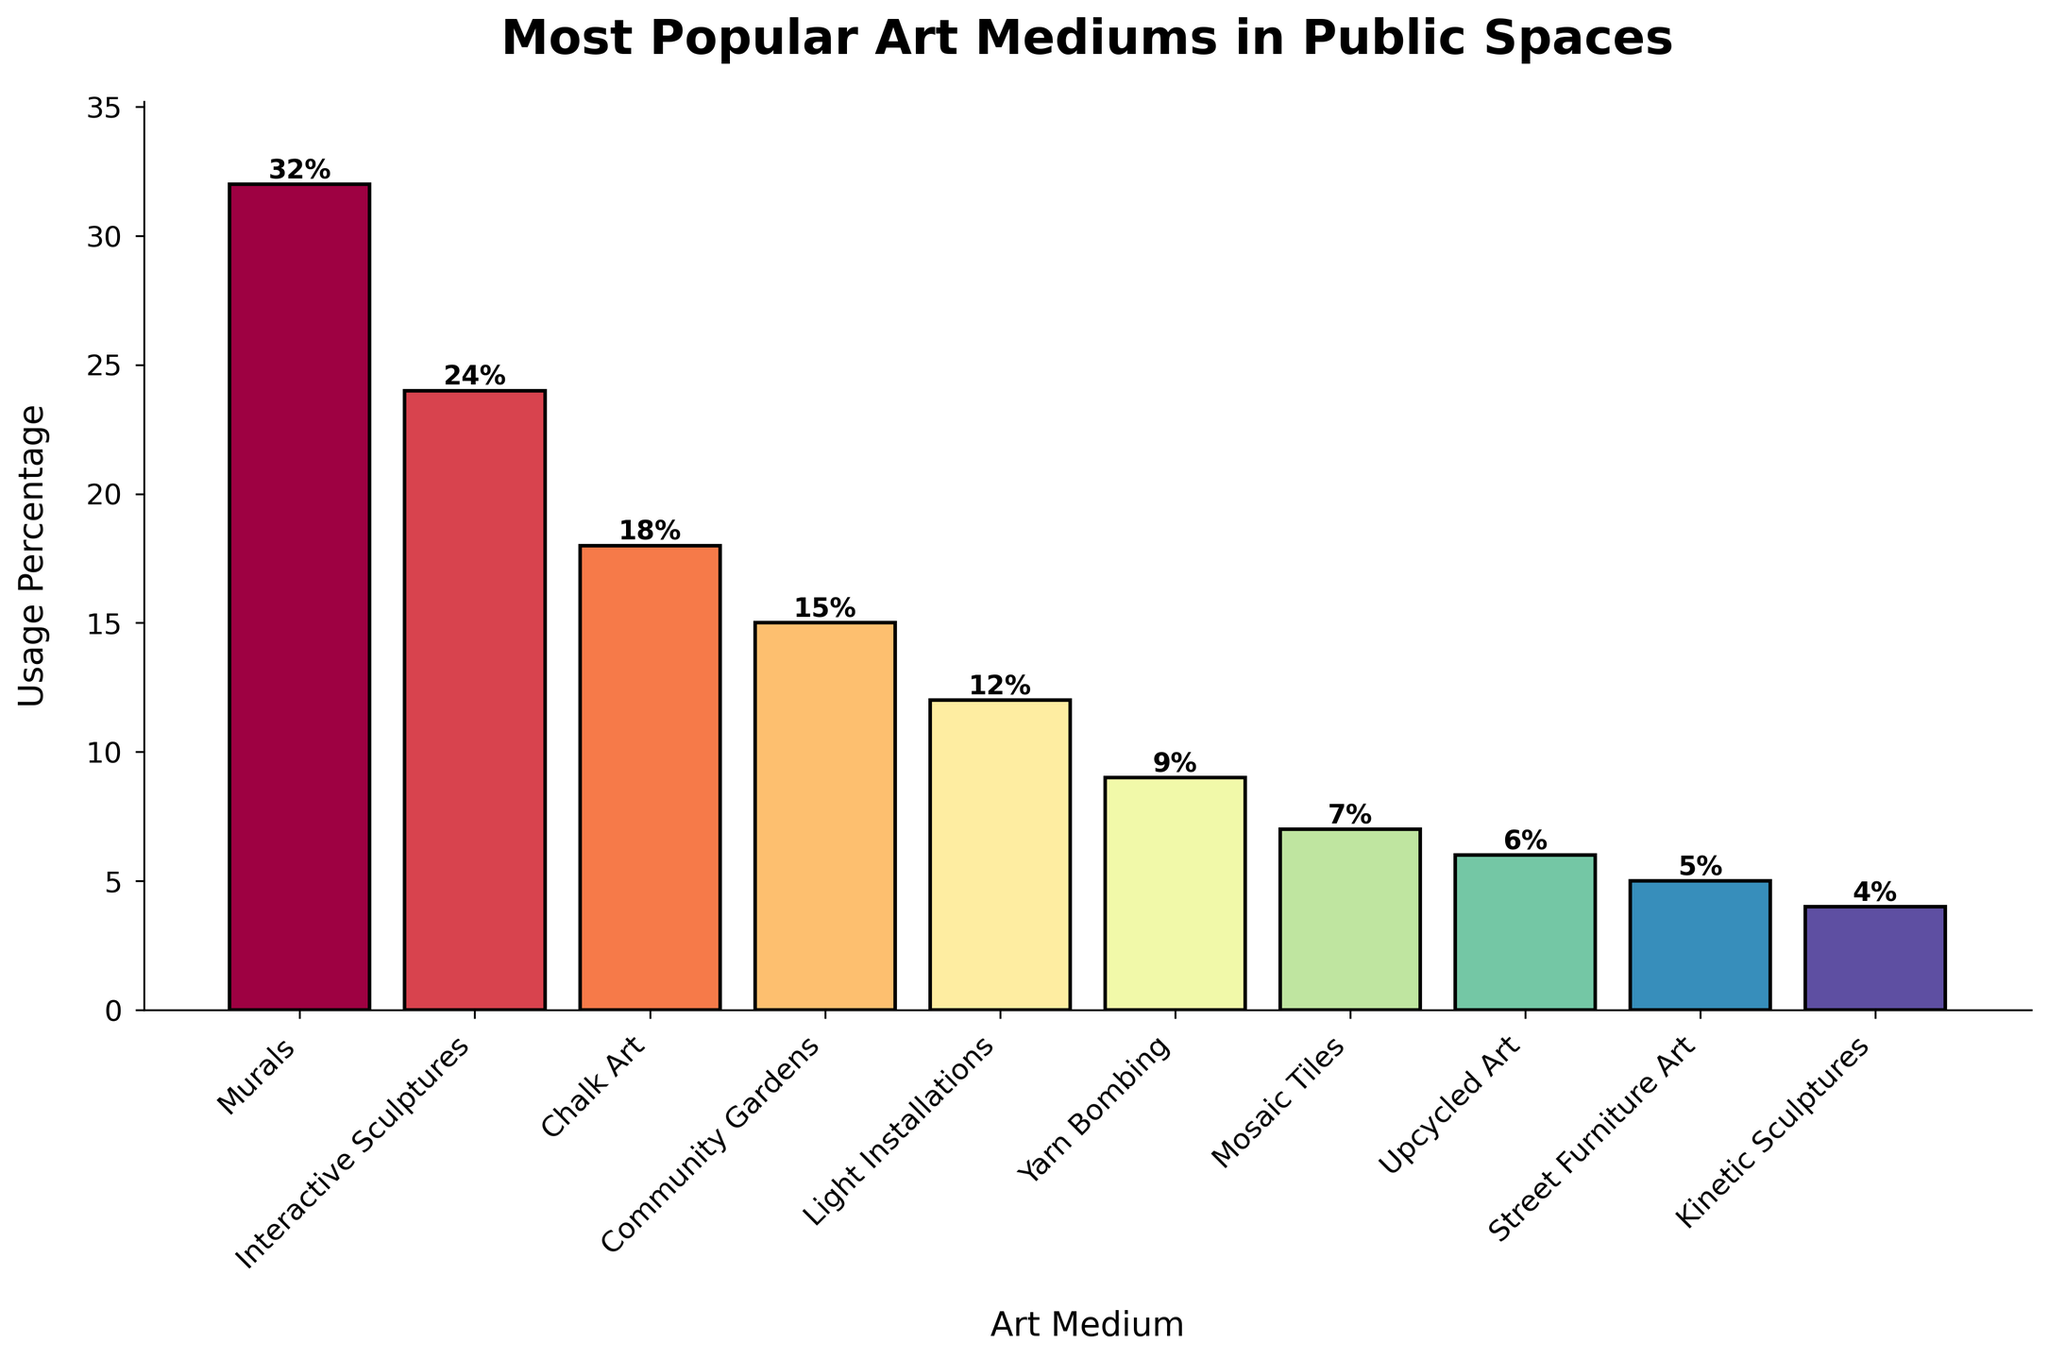Which art medium has the highest usage percentage? The highest bar in the figure represents the art medium with the largest usage percentage. By examining the bars, we can see that "Murals" have the highest bar with a usage percentage of 32%.
Answer: Murals Which two art mediums have the closest usage percentages? To determine the closest usage percentages, we need to compare the differences between the percentages of the art mediums. By inspection, "Yarn Bombing" and "Mosaic Tiles" have very close percentages of 9% and 7%, respectively.
Answer: Yarn Bombing and Mosaic Tiles What's the difference in usage percentage between the most popular and least popular art mediums? The most popular art medium is "Murals" with 32%, and the least popular is "Kinetic Sculptures" with 4%. The difference is calculated by subtracting the least from the most: 32% - 4% = 28%.
Answer: 28% How many art mediums have a usage percentage above 20%? By looking at the bars and their corresponding percentages, we see that "Murals" and "Interactive Sculptures" both have usage percentages above 20%. There are 2 such art mediums.
Answer: 2 Which art medium has a usage percentage of 12%? By finding the bar that has a height corresponding to 12%, we identify "Light Installations" as the art medium with this usage percentage.
Answer: Light Installations What is the combined usage percentage of "Chalk Art" and "Community Gardens"? The usage percentage of "Chalk Art" is 18% and that of "Community Gardens" is 15%. Adding these together, we get 18% + 15% = 33%.
Answer: 33% Are there more art mediums with a usage percentage below 10% or above 20%? There are four art mediums below 10%: "Yarn Bombing" (9%), "Mosaic Tiles" (7%), "Upcycled Art" (6%), and "Street Furniture Art" (5%). There are two mediums above 20%: "Murals" (32%) and "Interactive Sculptures" (24%). Therefore, there are more art mediums with a usage percentage below 10%.
Answer: Below 10% What is the average usage percentage of all the art mediums listed? To find the average, sum all the usage percentages and divide by the number of art mediums. The sum is 32 + 24 + 18 + 15 + 12 + 9 + 7 + 6 + 5 + 4 = 132%. There are 10 art mediums, so the average is 132%/10 = 13.2%.
Answer: 13.2% Rank the top three art mediums in terms of usage percentage. We need to order the art mediums by their usage percentage from highest to lowest. The top three are: 1) "Murals" (32%), 2) "Interactive Sculptures" (24%), and 3) "Chalk Art" (18%).
Answer: Murals, Interactive Sculptures, Chalk Art 